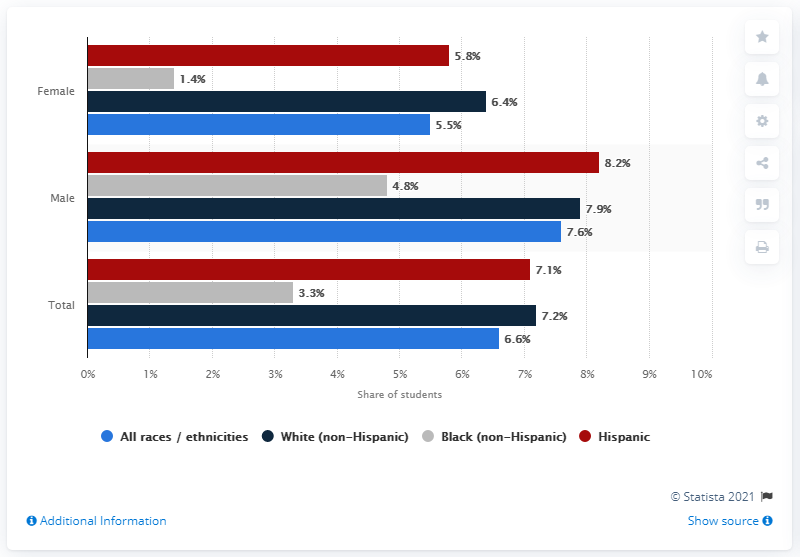Draw attention to some important aspects in this diagram. According to a recent study, 5.8% of Hispanic females have used drugs. The average percentage of Hispanic males and females who have used drugs is 2.4%. 